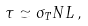Convert formula to latex. <formula><loc_0><loc_0><loc_500><loc_500>\tau \simeq \sigma _ { T } N L \, ,</formula> 